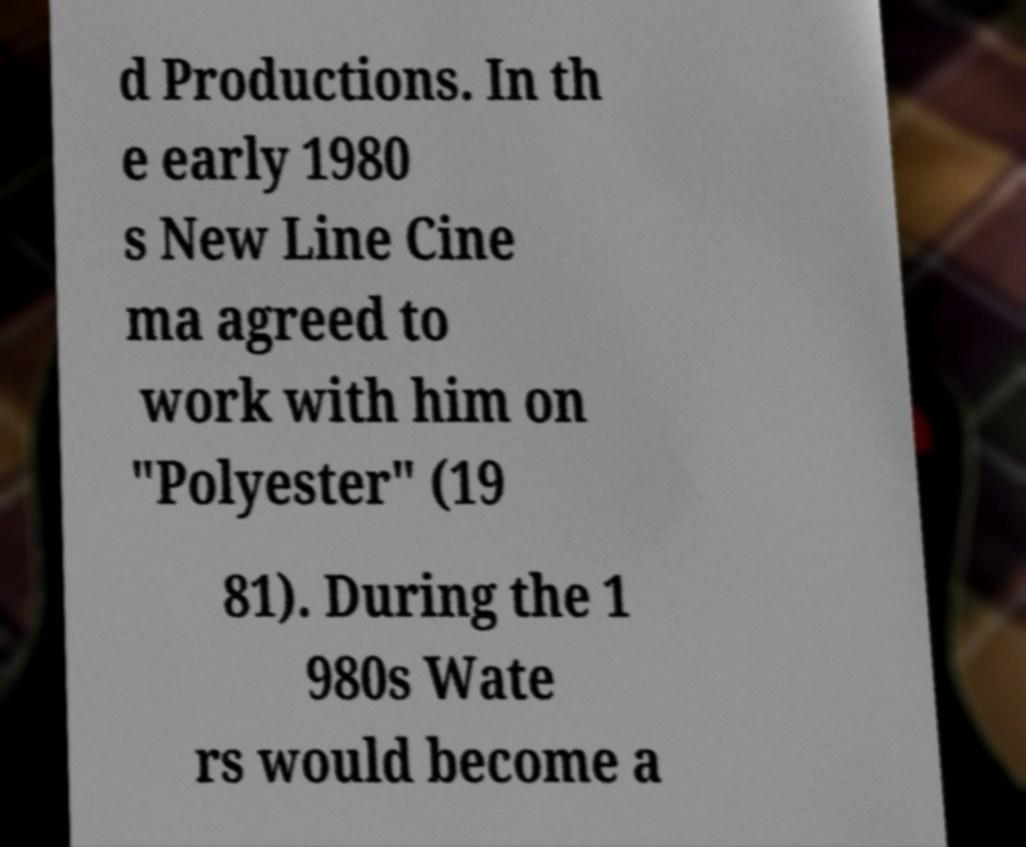Please identify and transcribe the text found in this image. d Productions. In th e early 1980 s New Line Cine ma agreed to work with him on "Polyester" (19 81). During the 1 980s Wate rs would become a 